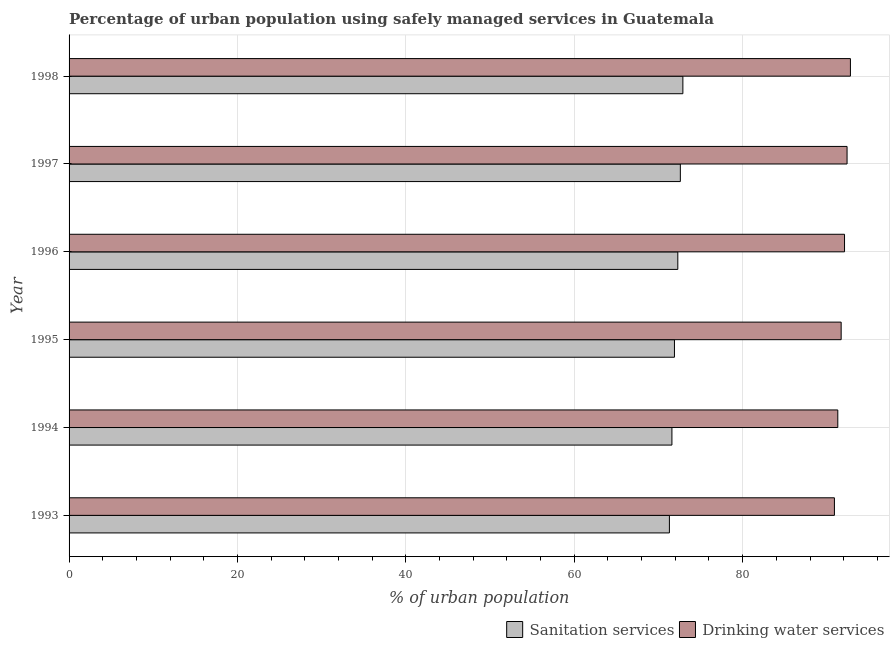How many groups of bars are there?
Provide a succinct answer. 6. Are the number of bars per tick equal to the number of legend labels?
Your response must be concise. Yes. Are the number of bars on each tick of the Y-axis equal?
Offer a very short reply. Yes. How many bars are there on the 4th tick from the top?
Make the answer very short. 2. What is the label of the 5th group of bars from the top?
Offer a terse response. 1994. In how many cases, is the number of bars for a given year not equal to the number of legend labels?
Offer a very short reply. 0. What is the percentage of urban population who used sanitation services in 1998?
Ensure brevity in your answer.  72.9. Across all years, what is the maximum percentage of urban population who used sanitation services?
Provide a succinct answer. 72.9. Across all years, what is the minimum percentage of urban population who used drinking water services?
Your response must be concise. 90.9. In which year was the percentage of urban population who used drinking water services minimum?
Provide a succinct answer. 1993. What is the total percentage of urban population who used drinking water services in the graph?
Your answer should be compact. 551.2. What is the difference between the percentage of urban population who used sanitation services in 1994 and that in 1998?
Your answer should be compact. -1.3. What is the difference between the percentage of urban population who used drinking water services in 1997 and the percentage of urban population who used sanitation services in 1993?
Make the answer very short. 21.1. What is the average percentage of urban population who used sanitation services per year?
Make the answer very short. 72.1. In the year 1995, what is the difference between the percentage of urban population who used drinking water services and percentage of urban population who used sanitation services?
Your answer should be very brief. 19.8. What is the ratio of the percentage of urban population who used sanitation services in 1993 to that in 1997?
Your answer should be very brief. 0.98. Is the percentage of urban population who used drinking water services in 1996 less than that in 1997?
Provide a succinct answer. Yes. What is the difference between the highest and the lowest percentage of urban population who used drinking water services?
Make the answer very short. 1.9. In how many years, is the percentage of urban population who used sanitation services greater than the average percentage of urban population who used sanitation services taken over all years?
Provide a short and direct response. 3. What does the 2nd bar from the top in 1995 represents?
Your answer should be very brief. Sanitation services. What does the 1st bar from the bottom in 1996 represents?
Provide a short and direct response. Sanitation services. Are all the bars in the graph horizontal?
Make the answer very short. Yes. Are the values on the major ticks of X-axis written in scientific E-notation?
Your response must be concise. No. Does the graph contain any zero values?
Give a very brief answer. No. Does the graph contain grids?
Your response must be concise. Yes. How are the legend labels stacked?
Ensure brevity in your answer.  Horizontal. What is the title of the graph?
Make the answer very short. Percentage of urban population using safely managed services in Guatemala. What is the label or title of the X-axis?
Your answer should be very brief. % of urban population. What is the % of urban population of Sanitation services in 1993?
Provide a succinct answer. 71.3. What is the % of urban population of Drinking water services in 1993?
Your answer should be compact. 90.9. What is the % of urban population in Sanitation services in 1994?
Make the answer very short. 71.6. What is the % of urban population of Drinking water services in 1994?
Keep it short and to the point. 91.3. What is the % of urban population in Sanitation services in 1995?
Provide a succinct answer. 71.9. What is the % of urban population of Drinking water services in 1995?
Make the answer very short. 91.7. What is the % of urban population in Sanitation services in 1996?
Offer a terse response. 72.3. What is the % of urban population in Drinking water services in 1996?
Provide a short and direct response. 92.1. What is the % of urban population in Sanitation services in 1997?
Provide a succinct answer. 72.6. What is the % of urban population in Drinking water services in 1997?
Your response must be concise. 92.4. What is the % of urban population in Sanitation services in 1998?
Offer a very short reply. 72.9. What is the % of urban population in Drinking water services in 1998?
Your answer should be very brief. 92.8. Across all years, what is the maximum % of urban population of Sanitation services?
Make the answer very short. 72.9. Across all years, what is the maximum % of urban population in Drinking water services?
Your answer should be compact. 92.8. Across all years, what is the minimum % of urban population in Sanitation services?
Offer a terse response. 71.3. Across all years, what is the minimum % of urban population of Drinking water services?
Provide a succinct answer. 90.9. What is the total % of urban population in Sanitation services in the graph?
Your answer should be compact. 432.6. What is the total % of urban population in Drinking water services in the graph?
Your answer should be compact. 551.2. What is the difference between the % of urban population in Drinking water services in 1993 and that in 1996?
Your response must be concise. -1.2. What is the difference between the % of urban population in Drinking water services in 1994 and that in 1995?
Give a very brief answer. -0.4. What is the difference between the % of urban population in Sanitation services in 1994 and that in 1998?
Keep it short and to the point. -1.3. What is the difference between the % of urban population of Sanitation services in 1995 and that in 1996?
Keep it short and to the point. -0.4. What is the difference between the % of urban population in Drinking water services in 1995 and that in 1996?
Provide a succinct answer. -0.4. What is the difference between the % of urban population of Drinking water services in 1995 and that in 1997?
Offer a very short reply. -0.7. What is the difference between the % of urban population in Drinking water services in 1995 and that in 1998?
Offer a very short reply. -1.1. What is the difference between the % of urban population of Sanitation services in 1996 and that in 1997?
Offer a very short reply. -0.3. What is the difference between the % of urban population in Sanitation services in 1996 and that in 1998?
Provide a succinct answer. -0.6. What is the difference between the % of urban population in Sanitation services in 1997 and that in 1998?
Your answer should be very brief. -0.3. What is the difference between the % of urban population in Sanitation services in 1993 and the % of urban population in Drinking water services in 1994?
Offer a very short reply. -20. What is the difference between the % of urban population in Sanitation services in 1993 and the % of urban population in Drinking water services in 1995?
Your response must be concise. -20.4. What is the difference between the % of urban population in Sanitation services in 1993 and the % of urban population in Drinking water services in 1996?
Offer a terse response. -20.8. What is the difference between the % of urban population in Sanitation services in 1993 and the % of urban population in Drinking water services in 1997?
Keep it short and to the point. -21.1. What is the difference between the % of urban population in Sanitation services in 1993 and the % of urban population in Drinking water services in 1998?
Provide a succinct answer. -21.5. What is the difference between the % of urban population in Sanitation services in 1994 and the % of urban population in Drinking water services in 1995?
Provide a succinct answer. -20.1. What is the difference between the % of urban population in Sanitation services in 1994 and the % of urban population in Drinking water services in 1996?
Provide a short and direct response. -20.5. What is the difference between the % of urban population of Sanitation services in 1994 and the % of urban population of Drinking water services in 1997?
Your answer should be compact. -20.8. What is the difference between the % of urban population in Sanitation services in 1994 and the % of urban population in Drinking water services in 1998?
Make the answer very short. -21.2. What is the difference between the % of urban population in Sanitation services in 1995 and the % of urban population in Drinking water services in 1996?
Provide a short and direct response. -20.2. What is the difference between the % of urban population of Sanitation services in 1995 and the % of urban population of Drinking water services in 1997?
Your response must be concise. -20.5. What is the difference between the % of urban population of Sanitation services in 1995 and the % of urban population of Drinking water services in 1998?
Ensure brevity in your answer.  -20.9. What is the difference between the % of urban population of Sanitation services in 1996 and the % of urban population of Drinking water services in 1997?
Your answer should be very brief. -20.1. What is the difference between the % of urban population in Sanitation services in 1996 and the % of urban population in Drinking water services in 1998?
Your response must be concise. -20.5. What is the difference between the % of urban population of Sanitation services in 1997 and the % of urban population of Drinking water services in 1998?
Ensure brevity in your answer.  -20.2. What is the average % of urban population of Sanitation services per year?
Make the answer very short. 72.1. What is the average % of urban population of Drinking water services per year?
Your response must be concise. 91.87. In the year 1993, what is the difference between the % of urban population in Sanitation services and % of urban population in Drinking water services?
Give a very brief answer. -19.6. In the year 1994, what is the difference between the % of urban population of Sanitation services and % of urban population of Drinking water services?
Give a very brief answer. -19.7. In the year 1995, what is the difference between the % of urban population in Sanitation services and % of urban population in Drinking water services?
Give a very brief answer. -19.8. In the year 1996, what is the difference between the % of urban population of Sanitation services and % of urban population of Drinking water services?
Your answer should be compact. -19.8. In the year 1997, what is the difference between the % of urban population of Sanitation services and % of urban population of Drinking water services?
Offer a very short reply. -19.8. In the year 1998, what is the difference between the % of urban population of Sanitation services and % of urban population of Drinking water services?
Your answer should be compact. -19.9. What is the ratio of the % of urban population in Sanitation services in 1993 to that in 1994?
Ensure brevity in your answer.  1. What is the ratio of the % of urban population in Drinking water services in 1993 to that in 1994?
Keep it short and to the point. 1. What is the ratio of the % of urban population of Sanitation services in 1993 to that in 1995?
Your response must be concise. 0.99. What is the ratio of the % of urban population of Sanitation services in 1993 to that in 1996?
Keep it short and to the point. 0.99. What is the ratio of the % of urban population of Drinking water services in 1993 to that in 1996?
Make the answer very short. 0.99. What is the ratio of the % of urban population in Sanitation services in 1993 to that in 1997?
Keep it short and to the point. 0.98. What is the ratio of the % of urban population in Drinking water services in 1993 to that in 1997?
Your answer should be compact. 0.98. What is the ratio of the % of urban population in Sanitation services in 1993 to that in 1998?
Offer a terse response. 0.98. What is the ratio of the % of urban population of Drinking water services in 1993 to that in 1998?
Your answer should be very brief. 0.98. What is the ratio of the % of urban population of Sanitation services in 1994 to that in 1995?
Provide a succinct answer. 1. What is the ratio of the % of urban population in Drinking water services in 1994 to that in 1995?
Make the answer very short. 1. What is the ratio of the % of urban population of Sanitation services in 1994 to that in 1996?
Your answer should be very brief. 0.99. What is the ratio of the % of urban population of Drinking water services in 1994 to that in 1996?
Your answer should be compact. 0.99. What is the ratio of the % of urban population in Sanitation services in 1994 to that in 1997?
Provide a succinct answer. 0.99. What is the ratio of the % of urban population of Sanitation services in 1994 to that in 1998?
Offer a very short reply. 0.98. What is the ratio of the % of urban population in Drinking water services in 1994 to that in 1998?
Your answer should be very brief. 0.98. What is the ratio of the % of urban population of Sanitation services in 1995 to that in 1997?
Provide a succinct answer. 0.99. What is the ratio of the % of urban population of Sanitation services in 1995 to that in 1998?
Keep it short and to the point. 0.99. What is the ratio of the % of urban population of Sanitation services in 1996 to that in 1997?
Ensure brevity in your answer.  1. What is the ratio of the % of urban population in Drinking water services in 1996 to that in 1997?
Provide a short and direct response. 1. What is the ratio of the % of urban population of Drinking water services in 1997 to that in 1998?
Offer a terse response. 1. What is the difference between the highest and the lowest % of urban population in Sanitation services?
Your answer should be very brief. 1.6. 